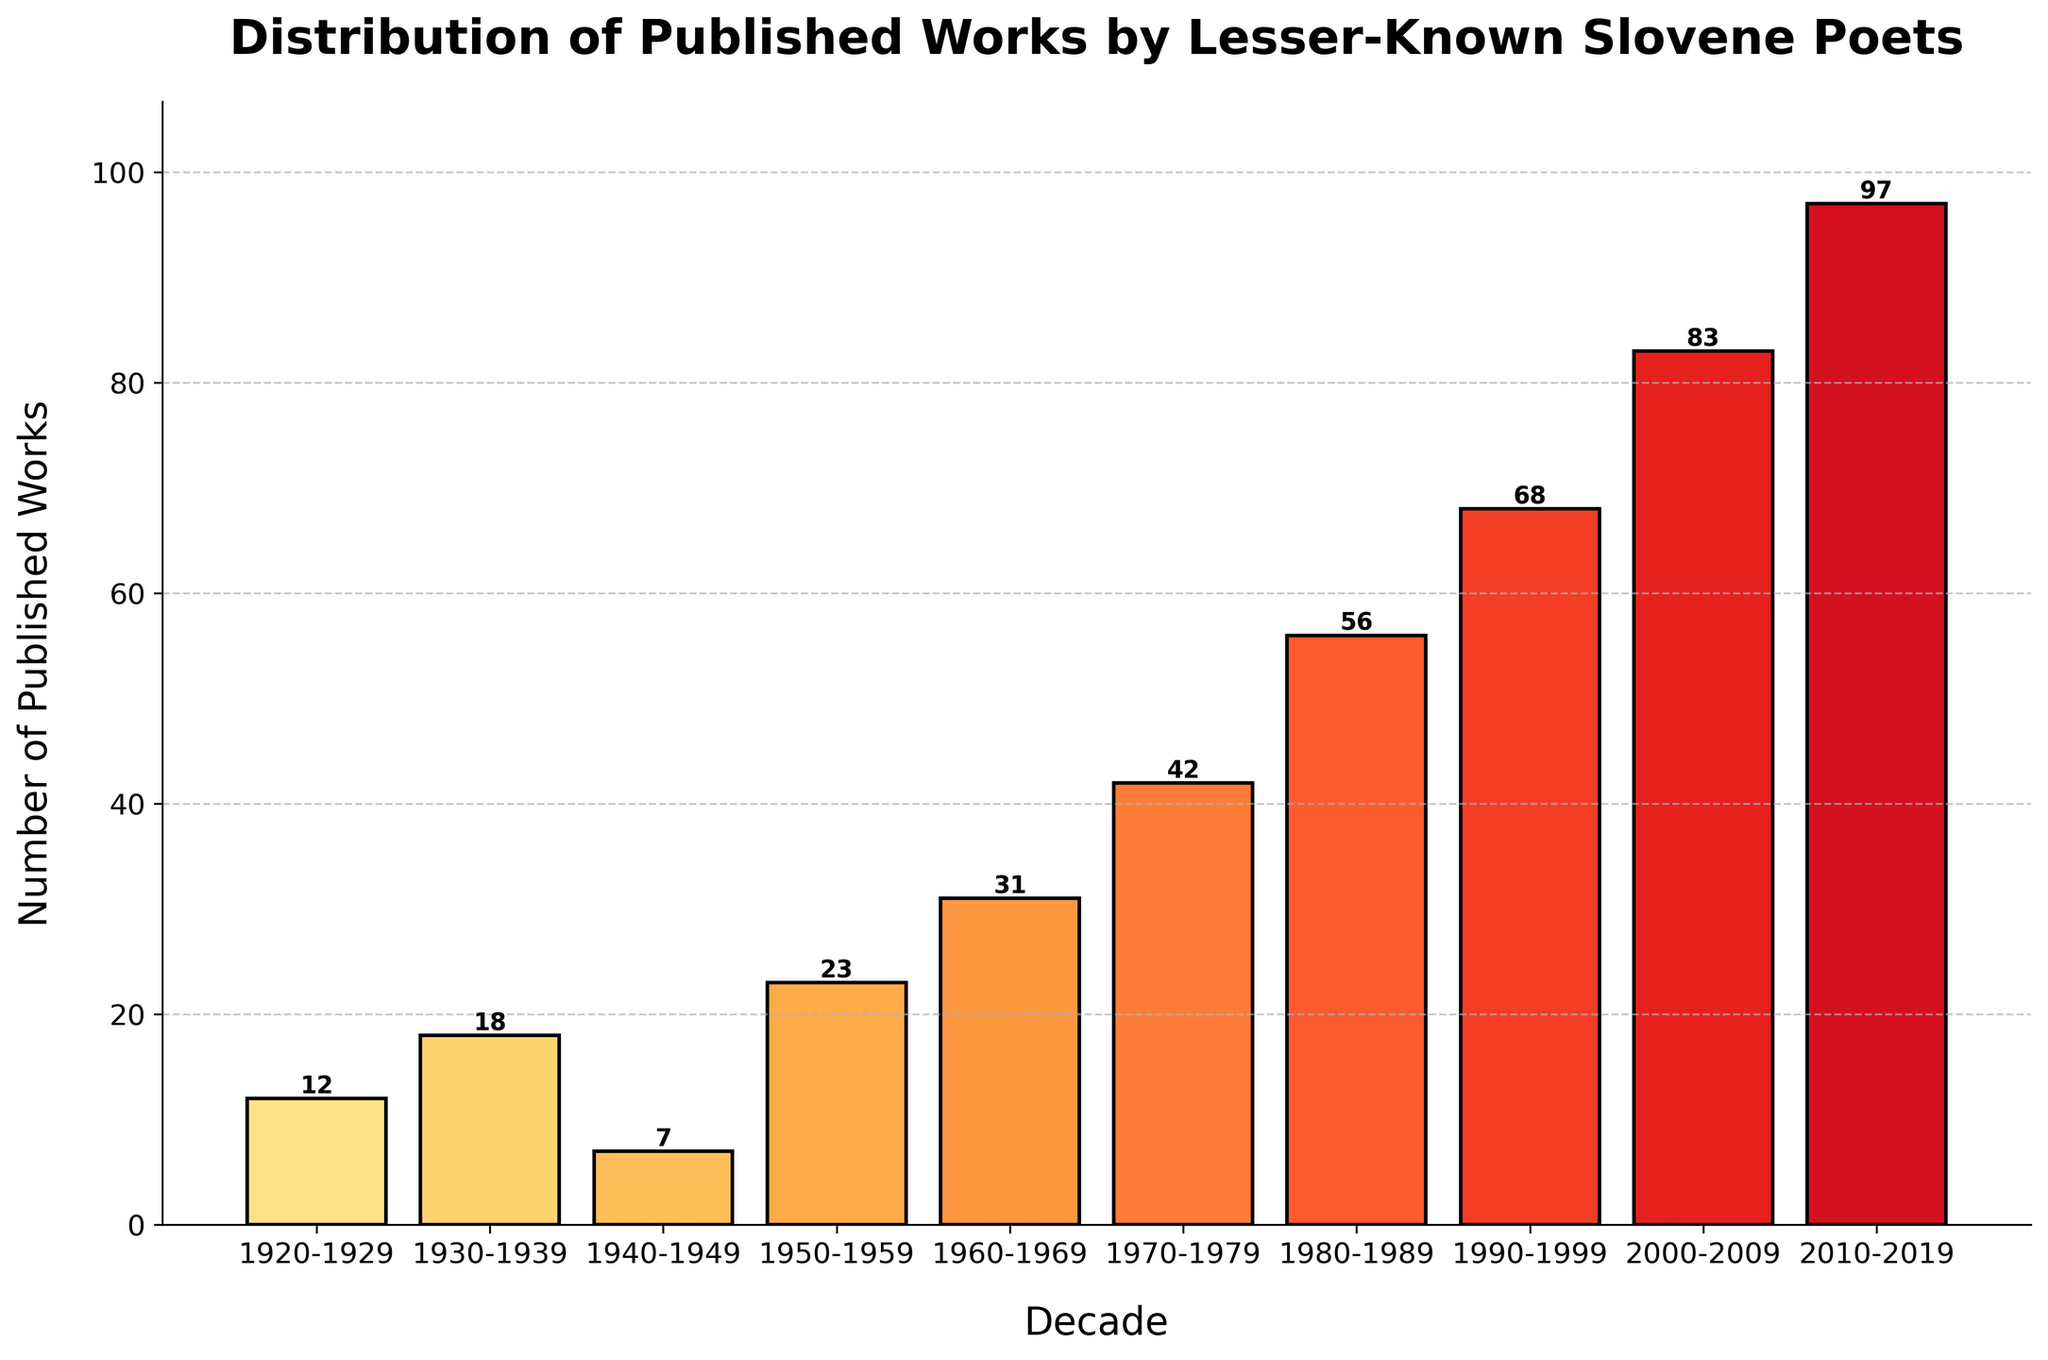Which decade has the highest number of published works? The tallest bar in the chart represents the decade with the highest number of published works. The bar for the 2010-2019 decade is the tallest.
Answer: 2010-2019 What's the total number of published works from 1940 to 1969? Add the number of published works from the decades 1940-1949, 1950-1959, and 1960-1969. The values are 7 (1940-1949) + 23 (1950-1959) + 31 (1960-1969) = 61.
Answer: 61 By how much did the number of published works increase from the 1950s to the 1980s? Subtract the number of published works in the 1950-1959 decade from that in the 1980-1989 decade. The values are 56 (1980-1989) - 23 (1950-1959) = 33.
Answer: 33 Which two consecutive decades show the greatest increase in published works? Compare the differences between each pair of consecutive decades. The largest increase is between 2000-2009, which has 83, and 2010-2019, which has 97. The difference is 97 - 83 = 14.
Answer: 2000-2009 and 2010-2019 What is the average number of published works per decade for the period from 1920-2019? Sum the total number of published works from 1920 to 2019 and divide by the number of decades. The sum is 12 + 18 + 7 + 23 + 31 + 42 + 56 + 68 + 83 + 97 = 437. There are 10 decades, so the average is 437 / 10 = 43.7.
Answer: 43.7 What visual trend is observed in the distribution of published works from 1920 to 2019? Visually, the bars increase in height, showing an overall upward trend in the number of published works over time.
Answer: Upward trend By how much did the number of published works change from the 1920s to the 1930s? Subtract the number of published works in the 1920-1929 decade from that in the 1930-1939 decade. The values are 18 (1930-1939) - 12 (1920-1929) = 6.
Answer: 6 Between which decades does the highest visual bar color intensity appear? The most visually intense color, indicating the highest number of works, appears in the 2010-2019 decade.
Answer: 2010-2019 What is the proportion of published works in the 2010s compared to the 1920s? Divide the number of works published in the 2010-2019 decade by the number published in the 1920-1929 decade. 97 (2010-2019) / 12 (1920-1929) ≈ 8.08.
Answer: 8.08 